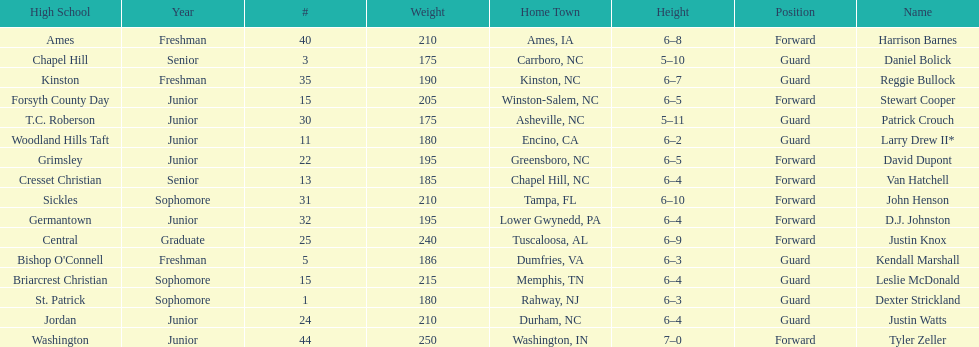How many players are not a junior? 9. 